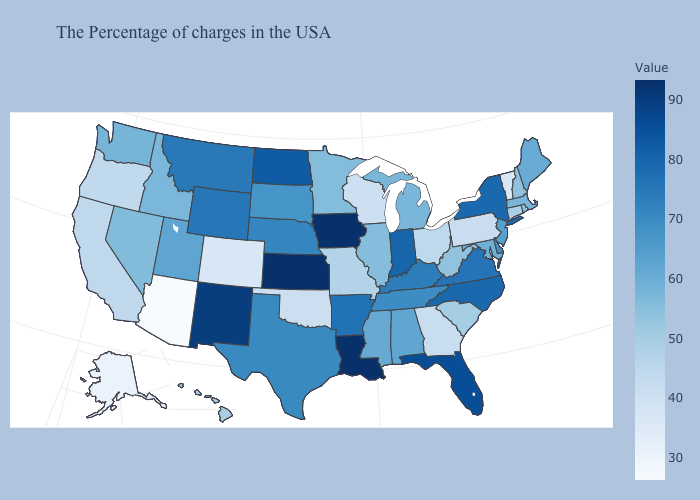Which states have the lowest value in the USA?
Keep it brief. Arizona. Does North Dakota have a higher value than Missouri?
Be succinct. Yes. Among the states that border Rhode Island , does Massachusetts have the lowest value?
Write a very short answer. No. Does Louisiana have the highest value in the South?
Short answer required. Yes. Among the states that border Wyoming , which have the lowest value?
Quick response, please. Colorado. Which states have the lowest value in the USA?
Write a very short answer. Arizona. Does North Carolina have the highest value in the USA?
Keep it brief. No. Among the states that border Delaware , which have the highest value?
Quick response, please. New Jersey. Does Arizona have the lowest value in the West?
Short answer required. Yes. Among the states that border Missouri , which have the lowest value?
Give a very brief answer. Oklahoma. 